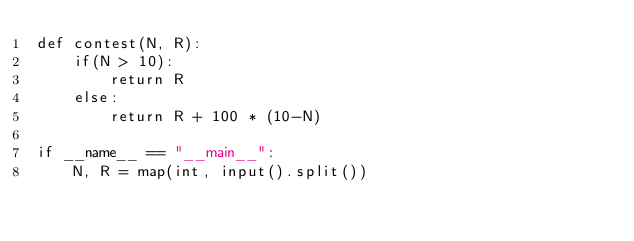<code> <loc_0><loc_0><loc_500><loc_500><_Python_>def contest(N, R):
    if(N > 10):
        return R
    else:
        return R + 100 * (10-N)

if __name__ == "__main__":
    N, R = map(int, input().split())</code> 